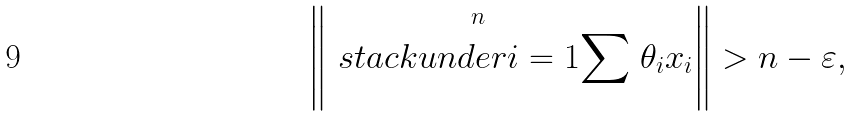<formula> <loc_0><loc_0><loc_500><loc_500>\left \| \stackrel { n } { \ s t a c k u n d e r { i = 1 } { \sum } } \theta _ { i } x _ { i } \right \| > n - \varepsilon ,</formula> 